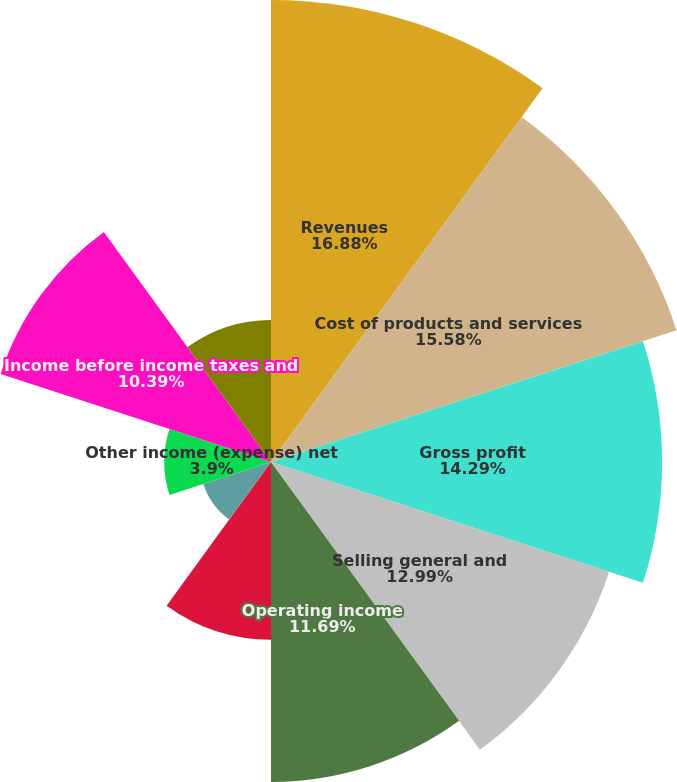<chart> <loc_0><loc_0><loc_500><loc_500><pie_chart><fcel>Revenues<fcel>Cost of products and services<fcel>Gross profit<fcel>Selling general and<fcel>Operating income<fcel>Interest and financial costs<fcel>Interest income<fcel>Other income (expense) net<fcel>Income before income taxes and<fcel>Provision for income taxes<nl><fcel>16.88%<fcel>15.58%<fcel>14.29%<fcel>12.99%<fcel>11.69%<fcel>6.49%<fcel>2.6%<fcel>3.9%<fcel>10.39%<fcel>5.19%<nl></chart> 